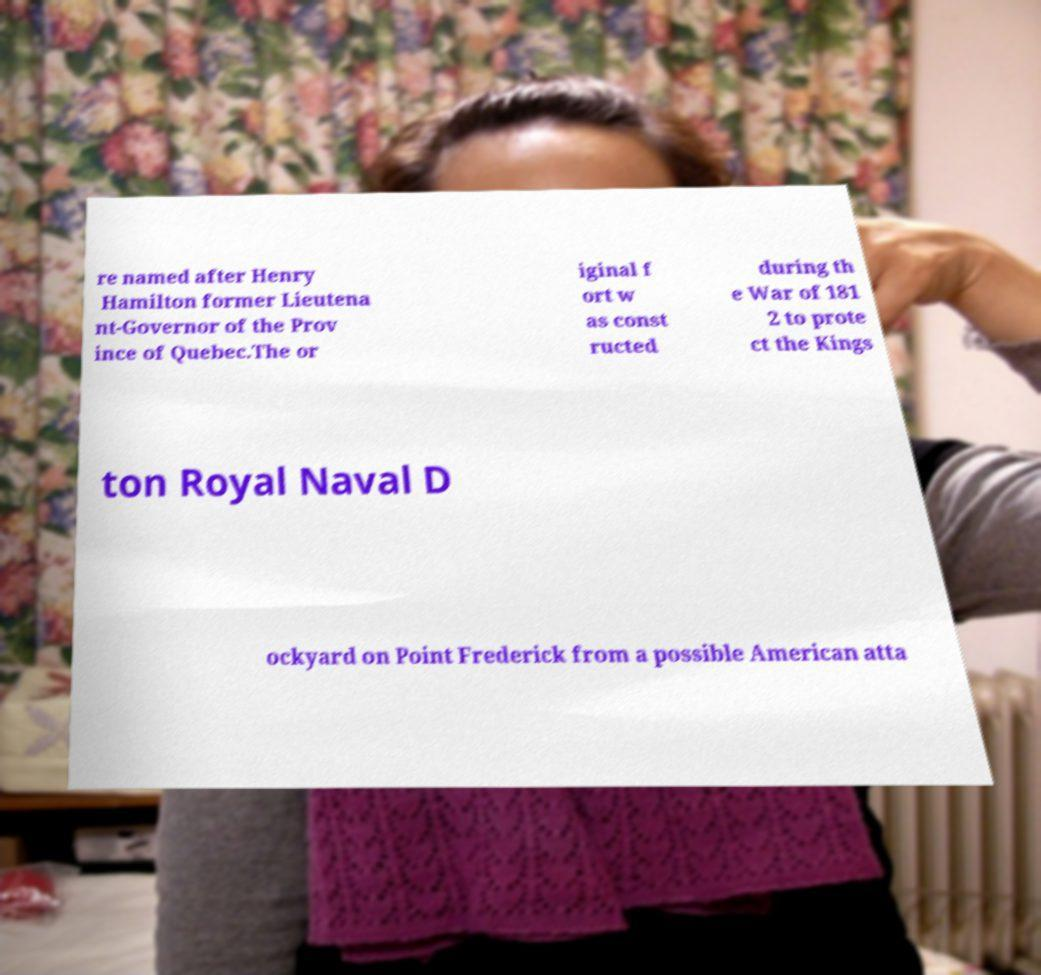Please read and relay the text visible in this image. What does it say? re named after Henry Hamilton former Lieutena nt-Governor of the Prov ince of Quebec.The or iginal f ort w as const ructed during th e War of 181 2 to prote ct the Kings ton Royal Naval D ockyard on Point Frederick from a possible American atta 